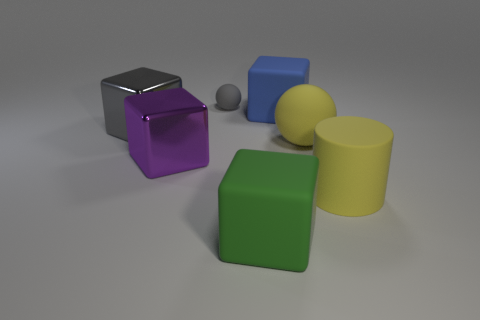Subtract all large gray blocks. How many blocks are left? 3 Subtract all purple cubes. How many cubes are left? 3 Add 2 tiny matte cubes. How many objects exist? 9 Subtract all blue blocks. Subtract all blue balls. How many blocks are left? 3 Subtract all cylinders. How many objects are left? 6 Add 2 big blue matte cubes. How many big blue matte cubes are left? 3 Add 3 gray things. How many gray things exist? 5 Subtract 1 yellow cylinders. How many objects are left? 6 Subtract all big metallic blocks. Subtract all red rubber objects. How many objects are left? 5 